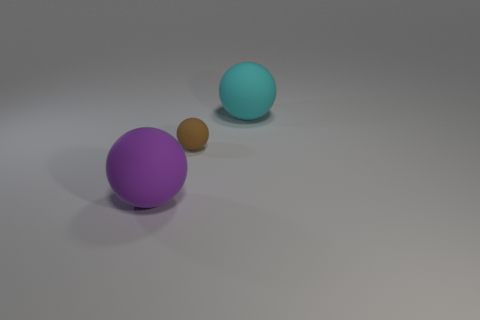Add 3 big things. How many objects exist? 6 Add 1 small things. How many small things are left? 2 Add 2 big rubber things. How many big rubber things exist? 4 Subtract 0 cyan cylinders. How many objects are left? 3 Subtract all large purple balls. Subtract all big things. How many objects are left? 0 